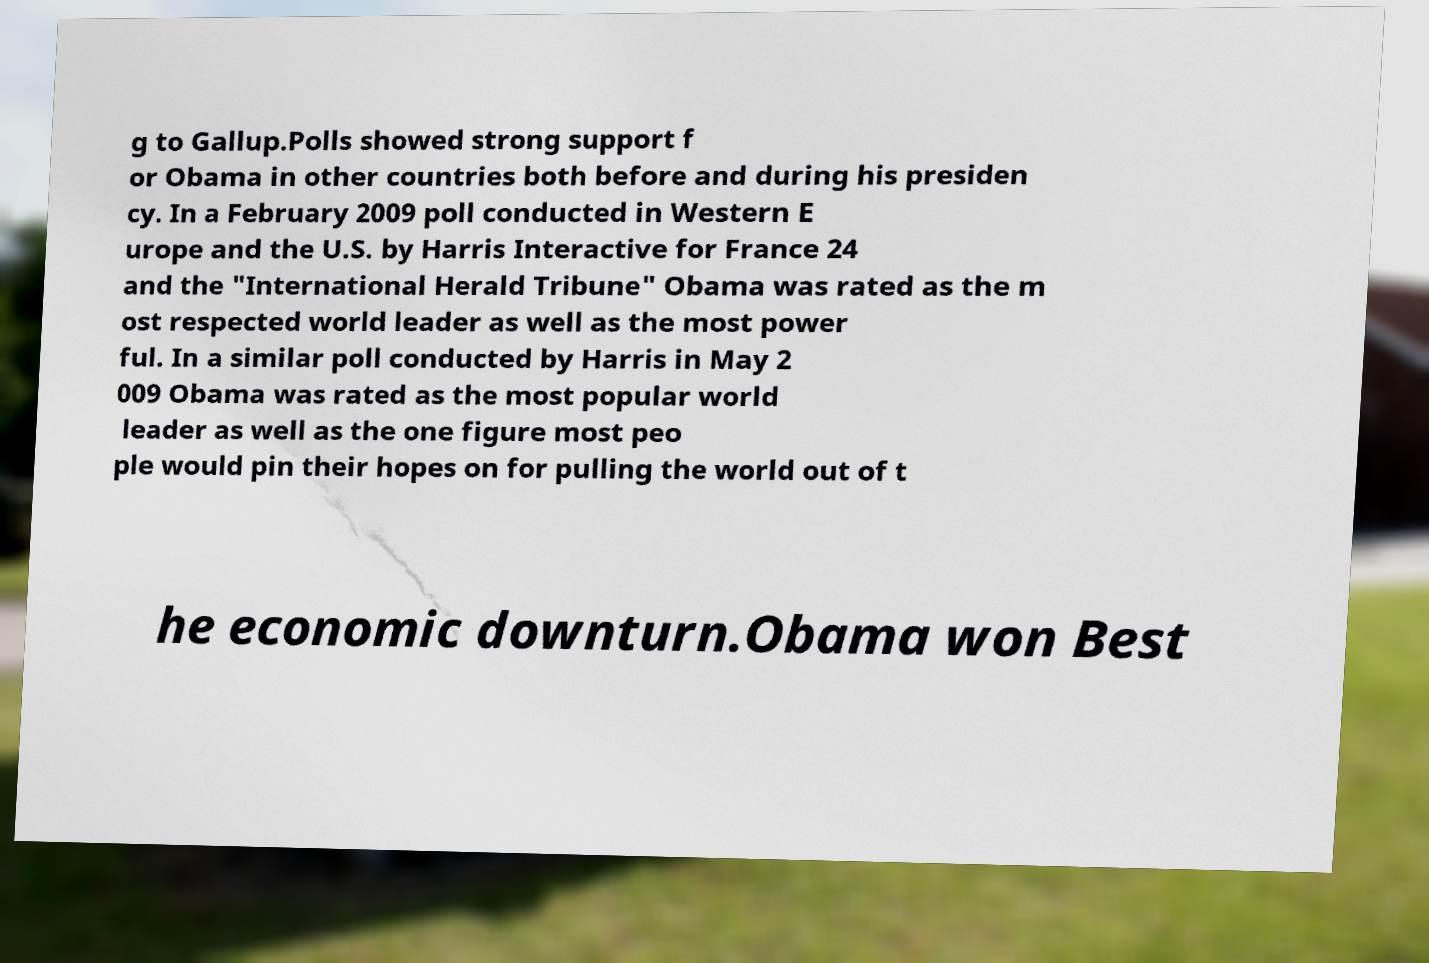There's text embedded in this image that I need extracted. Can you transcribe it verbatim? g to Gallup.Polls showed strong support f or Obama in other countries both before and during his presiden cy. In a February 2009 poll conducted in Western E urope and the U.S. by Harris Interactive for France 24 and the "International Herald Tribune" Obama was rated as the m ost respected world leader as well as the most power ful. In a similar poll conducted by Harris in May 2 009 Obama was rated as the most popular world leader as well as the one figure most peo ple would pin their hopes on for pulling the world out of t he economic downturn.Obama won Best 